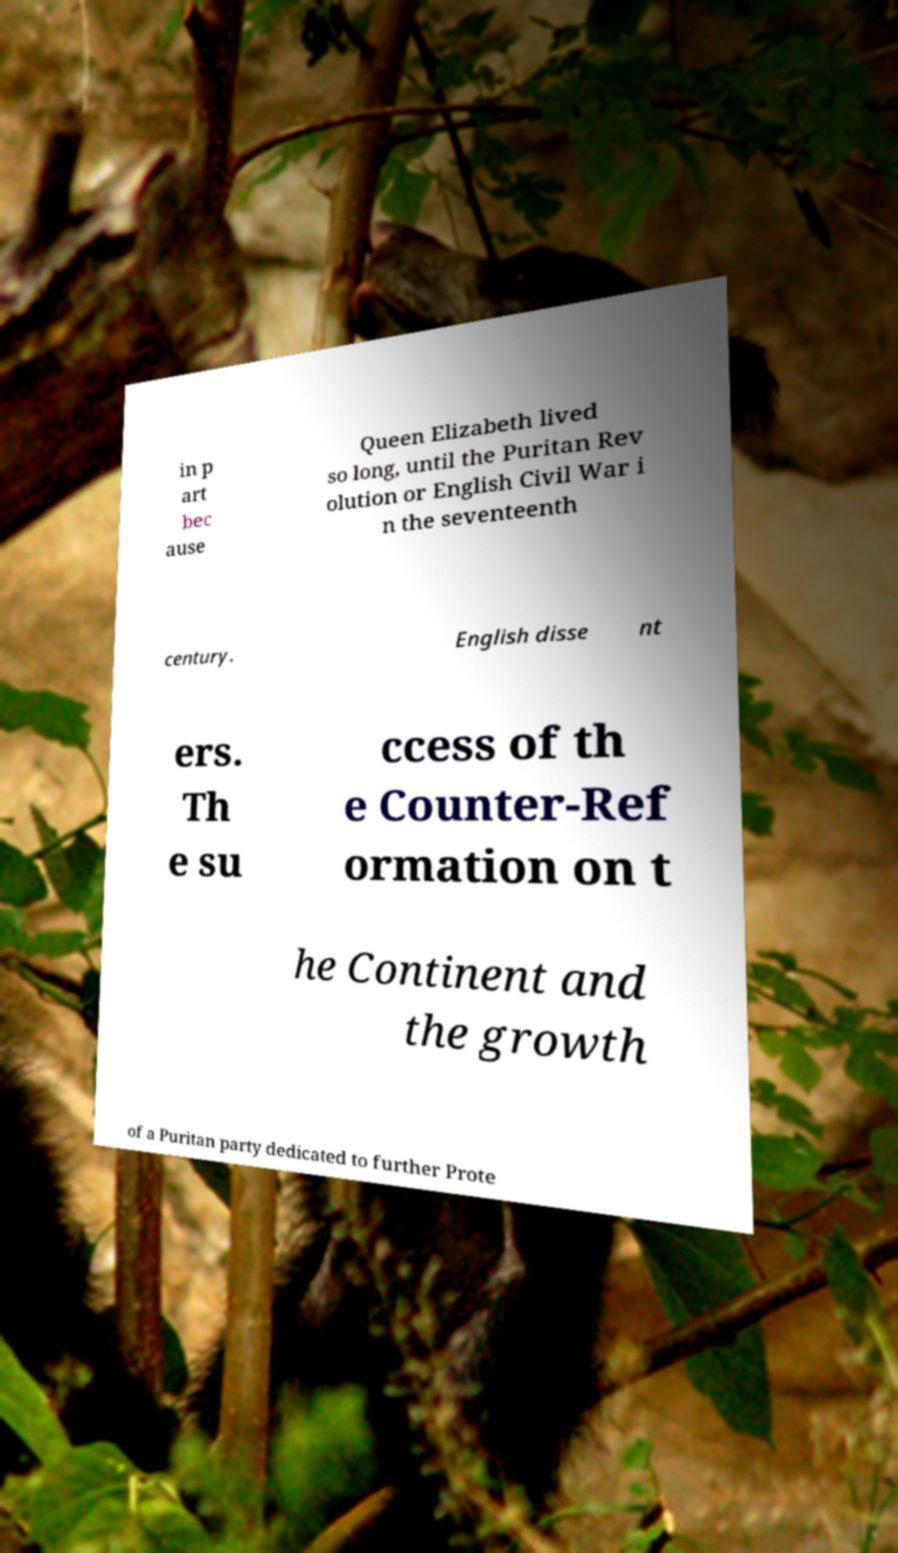For documentation purposes, I need the text within this image transcribed. Could you provide that? in p art bec ause Queen Elizabeth lived so long, until the Puritan Rev olution or English Civil War i n the seventeenth century. English disse nt ers. Th e su ccess of th e Counter-Ref ormation on t he Continent and the growth of a Puritan party dedicated to further Prote 